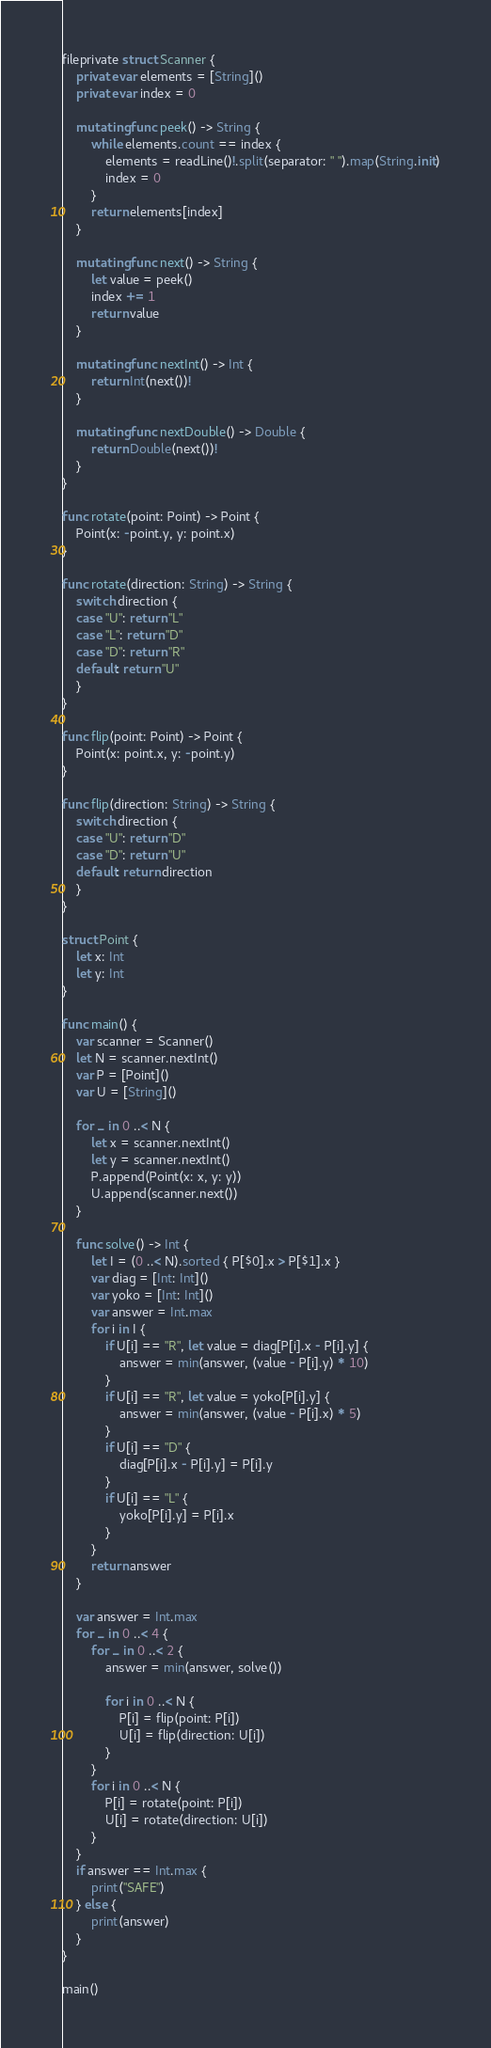Convert code to text. <code><loc_0><loc_0><loc_500><loc_500><_Swift_>fileprivate struct Scanner {
    private var elements = [String]()
    private var index = 0
    
    mutating func peek() -> String {
        while elements.count == index {
            elements = readLine()!.split(separator: " ").map(String.init)
            index = 0
        }
        return elements[index]
    }
    
    mutating func next() -> String {
        let value = peek()
        index += 1
        return value
    }
    
    mutating func nextInt() -> Int {
        return Int(next())!
    }
    
    mutating func nextDouble() -> Double {
        return Double(next())!
    }
}

func rotate(point: Point) -> Point {
    Point(x: -point.y, y: point.x)
}

func rotate(direction: String) -> String {
    switch direction {
    case "U": return "L"
    case "L": return "D"
    case "D": return "R"
    default: return "U"
    }
}

func flip(point: Point) -> Point {
    Point(x: point.x, y: -point.y)
}

func flip(direction: String) -> String {
    switch direction {
    case "U": return "D"
    case "D": return "U"
    default: return direction
    }
}

struct Point {
    let x: Int
    let y: Int
}

func main() {
    var scanner = Scanner()
    let N = scanner.nextInt()
    var P = [Point]()
    var U = [String]()
    
    for _ in 0 ..< N {
        let x = scanner.nextInt()
        let y = scanner.nextInt()
        P.append(Point(x: x, y: y))
        U.append(scanner.next())
    }
    
    func solve() -> Int {
        let I = (0 ..< N).sorted { P[$0].x > P[$1].x }
        var diag = [Int: Int]()
        var yoko = [Int: Int]()
        var answer = Int.max
        for i in I {
            if U[i] == "R", let value = diag[P[i].x - P[i].y] {
                answer = min(answer, (value - P[i].y) * 10)
            }
            if U[i] == "R", let value = yoko[P[i].y] {
                answer = min(answer, (value - P[i].x) * 5)
            }
            if U[i] == "D" {
                diag[P[i].x - P[i].y] = P[i].y
            }
            if U[i] == "L" {
                yoko[P[i].y] = P[i].x
            }
        }
        return answer
    }
    
    var answer = Int.max
    for _ in 0 ..< 4 {
        for _ in 0 ..< 2 {
            answer = min(answer, solve())
            
            for i in 0 ..< N {
                P[i] = flip(point: P[i])
                U[i] = flip(direction: U[i])
            }
        }
        for i in 0 ..< N {
            P[i] = rotate(point: P[i])
            U[i] = rotate(direction: U[i])
        }
    }
    if answer == Int.max {
        print("SAFE")
    } else {
        print(answer)
    }
}

main()
</code> 